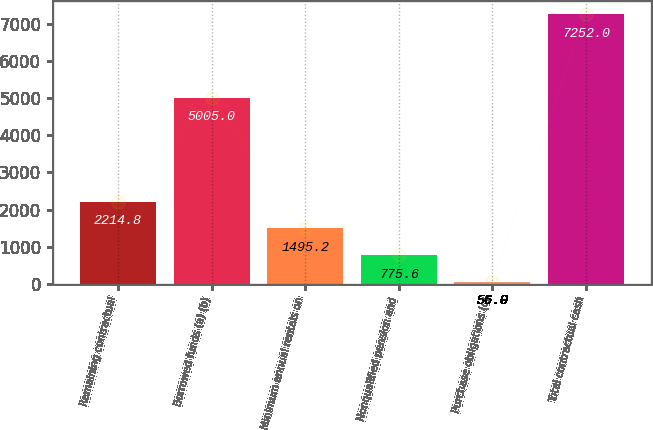Convert chart. <chart><loc_0><loc_0><loc_500><loc_500><bar_chart><fcel>Remaining contractual<fcel>Borrowed funds (a) (b)<fcel>Minimum annual rentals on<fcel>Nonqualified pension and<fcel>Purchase obligations (c)<fcel>Total contractual cash<nl><fcel>2214.8<fcel>5005<fcel>1495.2<fcel>775.6<fcel>56<fcel>7252<nl></chart> 